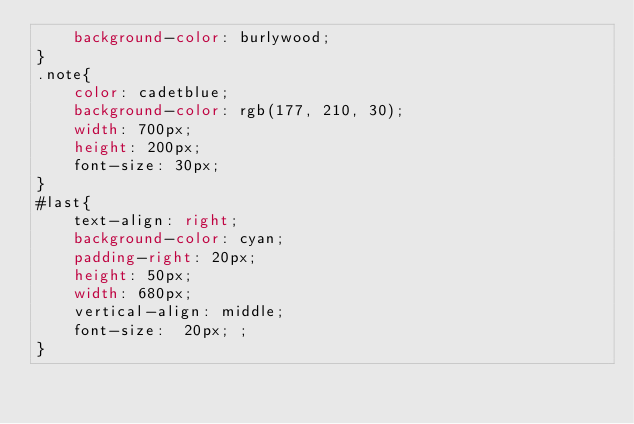<code> <loc_0><loc_0><loc_500><loc_500><_CSS_>    background-color: burlywood;
}
.note{
    color: cadetblue;
    background-color: rgb(177, 210, 30);
    width: 700px;
    height: 200px;
    font-size: 30px;
}
#last{
    text-align: right;
    background-color: cyan;
    padding-right: 20px;
    height: 50px;
    width: 680px;
    vertical-align: middle;
    font-size:  20px; ;
}</code> 